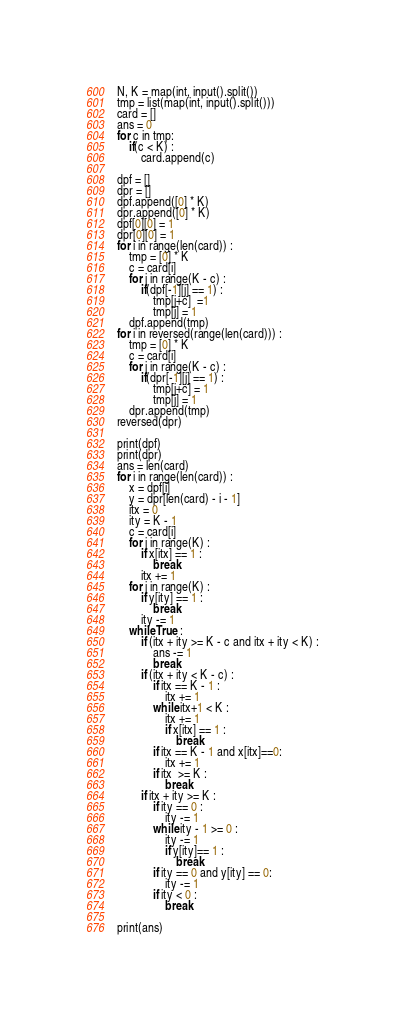<code> <loc_0><loc_0><loc_500><loc_500><_Python_>N, K = map(int, input().split())
tmp = list(map(int, input().split()))
card = []
ans = 0
for c in tmp:
    if(c < K) :
        card.append(c)

dpf = []
dpr = []
dpf.append([0] * K)
dpr.append([0] * K)
dpf[0][0] = 1
dpr[0][0] = 1
for i in range(len(card)) :
    tmp = [0] * K
    c = card[i]
    for j in range(K - c) :
        if(dpf[-1][j] == 1) :
            tmp[j+c]  =1
            tmp[j] = 1
    dpf.append(tmp)
for i in reversed(range(len(card))) :
    tmp = [0] * K
    c = card[i]
    for j in range(K - c) :
        if(dpr[-1][j] == 1) :
            tmp[j+c] = 1
            tmp[j] = 1
    dpr.append(tmp)
reversed(dpr)

print(dpf)
print(dpr)
ans = len(card)
for i in range(len(card)) :
    x = dpf[i]
    y = dpr[len(card) - i - 1]
    itx = 0
    ity = K - 1
    c = card[i]
    for j in range(K) :
        if x[itx] == 1 :
            break
        itx += 1
    for j in range(K) :
        if y[ity] == 1 :
            break
        ity -= 1
    while True :
        if (itx + ity >= K - c and itx + ity < K) :
            ans -= 1
            break
        if (itx + ity < K - c) :
            if itx == K - 1 :
                itx += 1
            while itx+1 < K :
                itx += 1
                if x[itx] == 1 :
                    break
            if itx == K - 1 and x[itx]==0:
                itx += 1
            if itx  >= K :
                break
        if itx + ity >= K :
            if ity == 0 :
                ity -= 1
            while ity - 1 >= 0 :
                ity -= 1
                if y[ity]== 1 :
                    break
            if ity == 0 and y[ity] == 0:
                ity -= 1
            if ity < 0 :
                break

print(ans)


</code> 